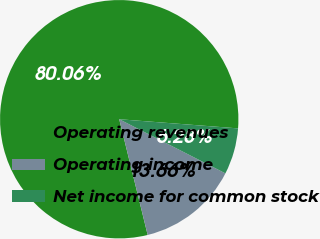Convert chart to OTSL. <chart><loc_0><loc_0><loc_500><loc_500><pie_chart><fcel>Operating revenues<fcel>Operating income<fcel>Net income for common stock<nl><fcel>80.06%<fcel>13.66%<fcel>6.28%<nl></chart> 